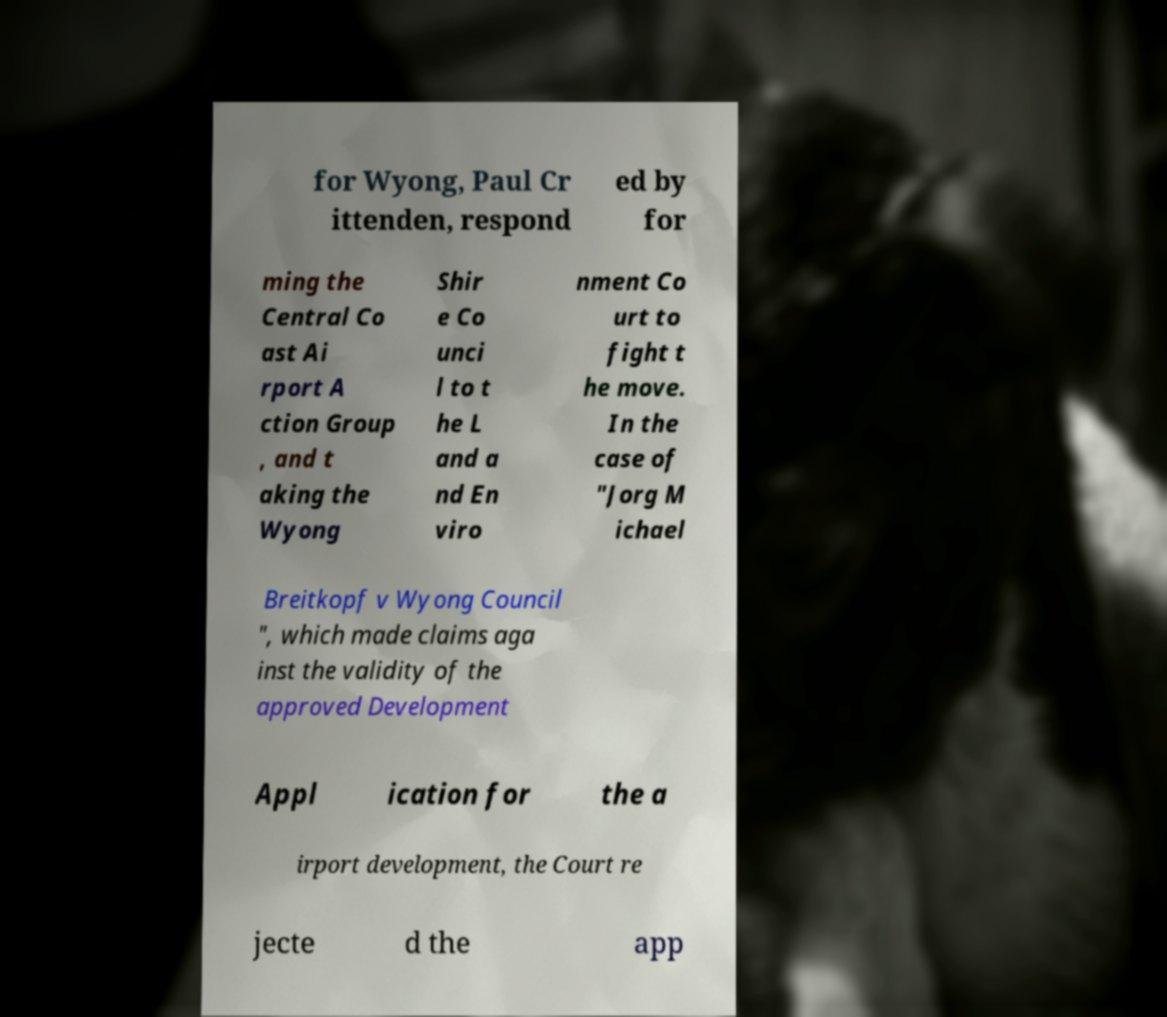For documentation purposes, I need the text within this image transcribed. Could you provide that? for Wyong, Paul Cr ittenden, respond ed by for ming the Central Co ast Ai rport A ction Group , and t aking the Wyong Shir e Co unci l to t he L and a nd En viro nment Co urt to fight t he move. In the case of "Jorg M ichael Breitkopf v Wyong Council ", which made claims aga inst the validity of the approved Development Appl ication for the a irport development, the Court re jecte d the app 